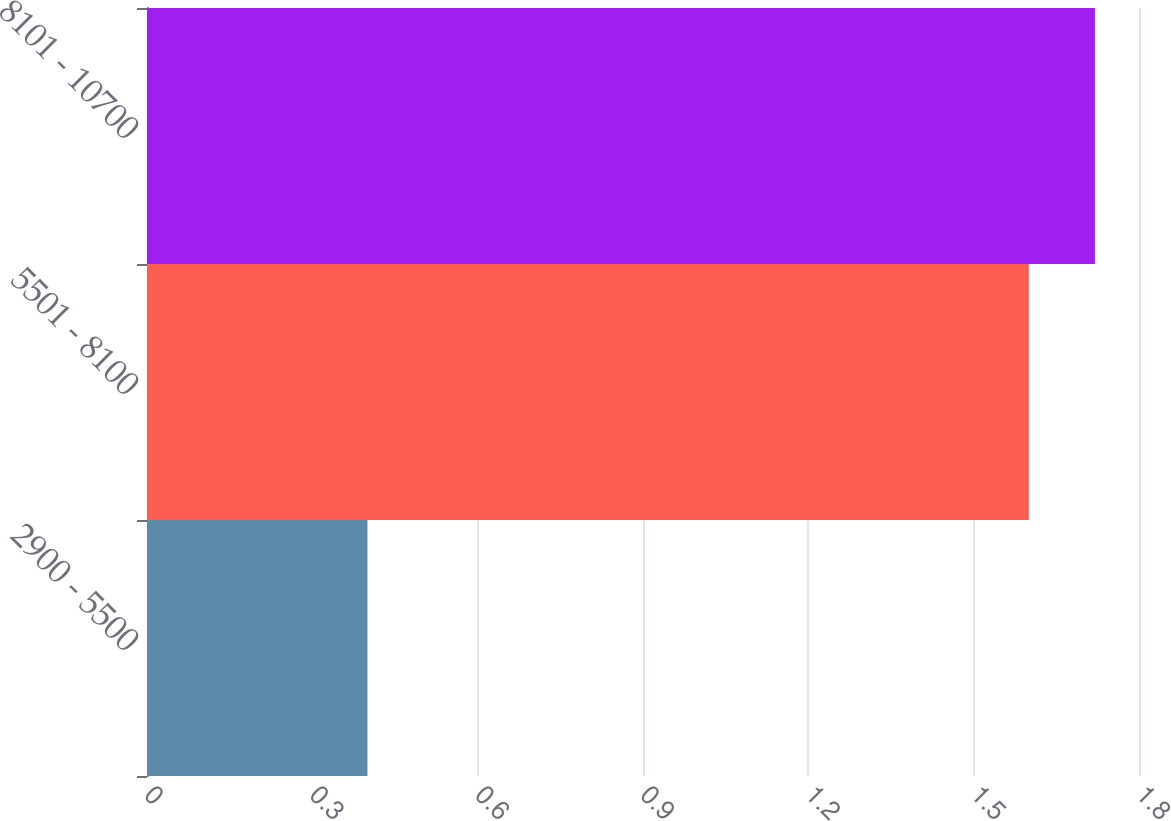Convert chart. <chart><loc_0><loc_0><loc_500><loc_500><bar_chart><fcel>2900 - 5500<fcel>5501 - 8100<fcel>8101 - 10700<nl><fcel>0.4<fcel>1.6<fcel>1.72<nl></chart> 